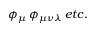<formula> <loc_0><loc_0><loc_500><loc_500>\phi _ { \mu } \, \phi _ { \mu \nu \lambda } \, e t c .</formula> 